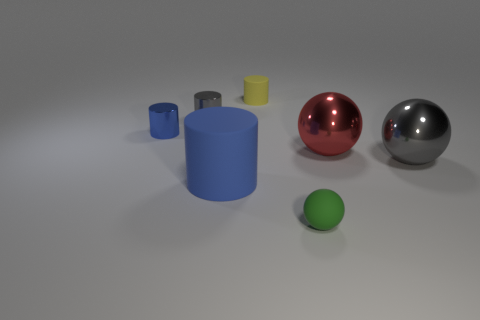How many objects are there in the image, and can you describe them? There are five objects displayed. From left to right, there is a small blue cylinder, a slightly larger grey cylinder, a small yellow cylinder, a large red sphere, and a large silver sphere. 